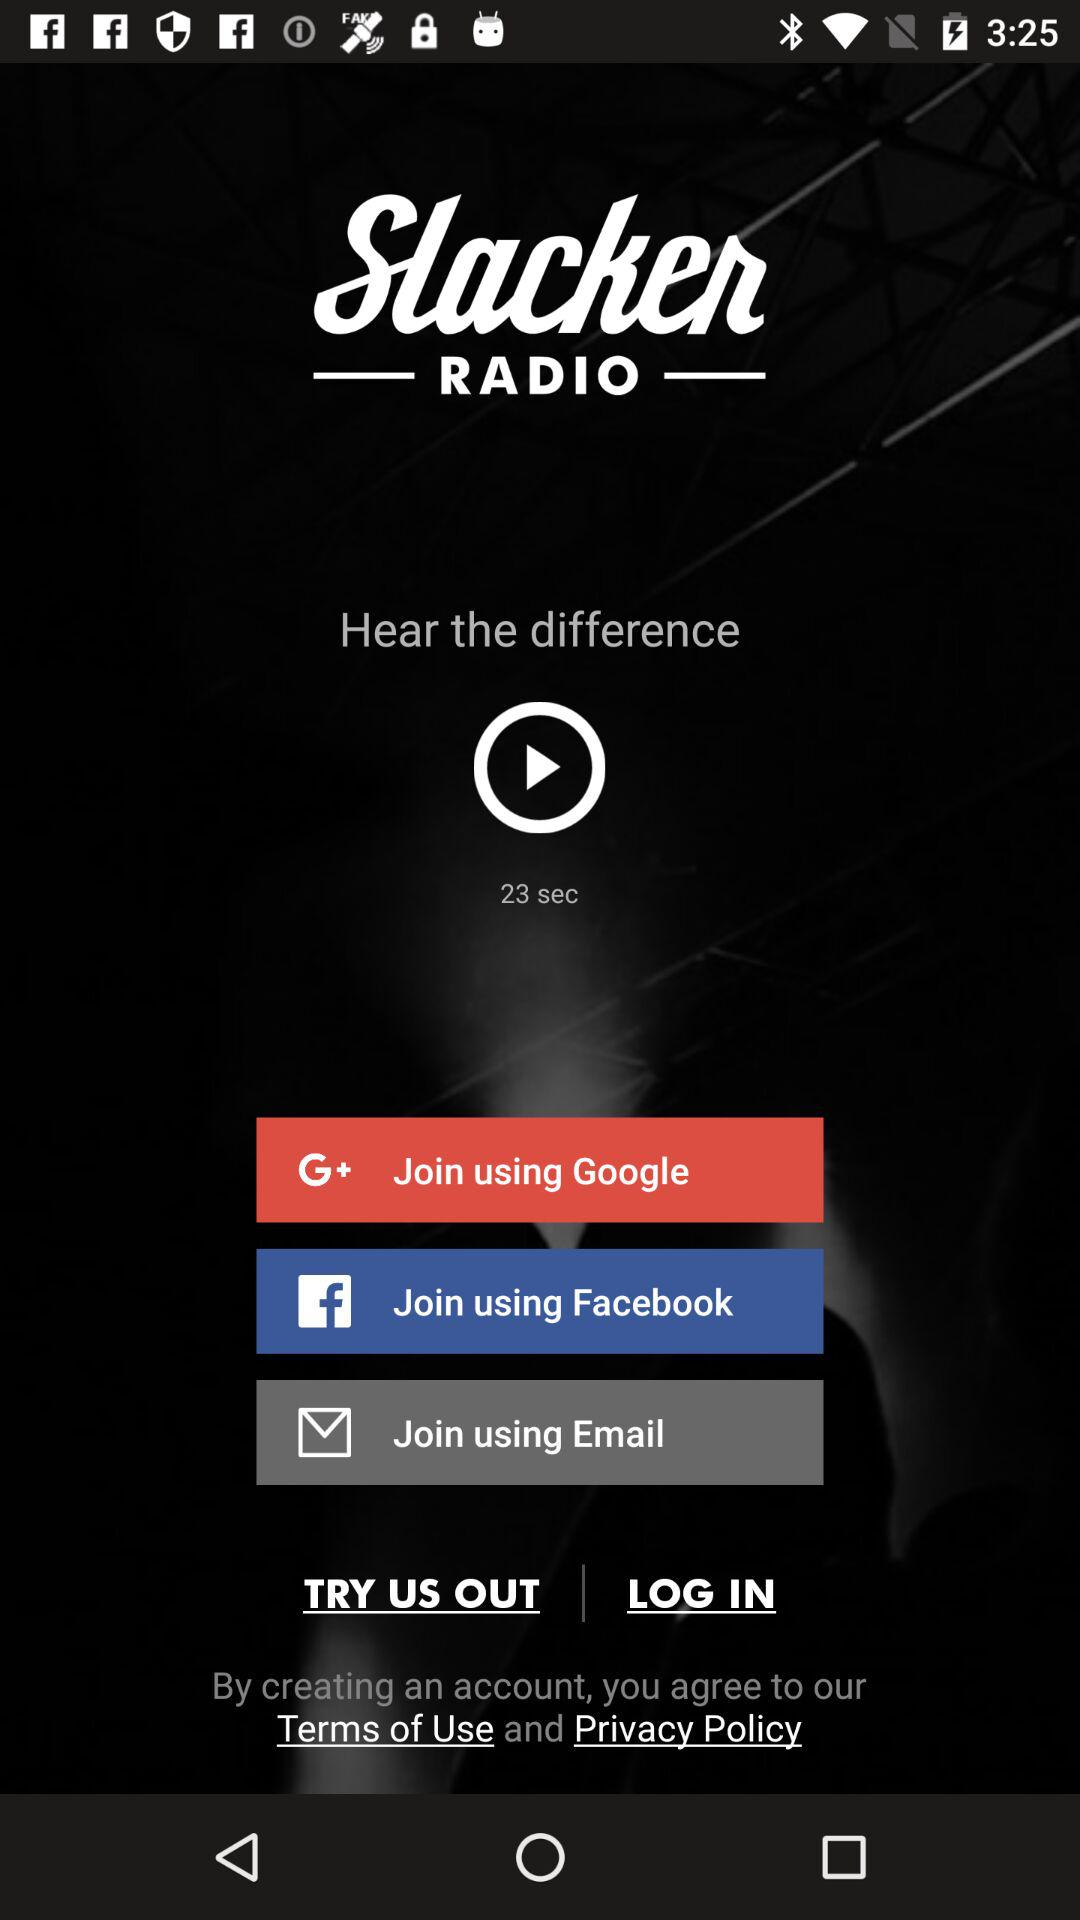What's the duration of the track? The duration is 23 seconds. 